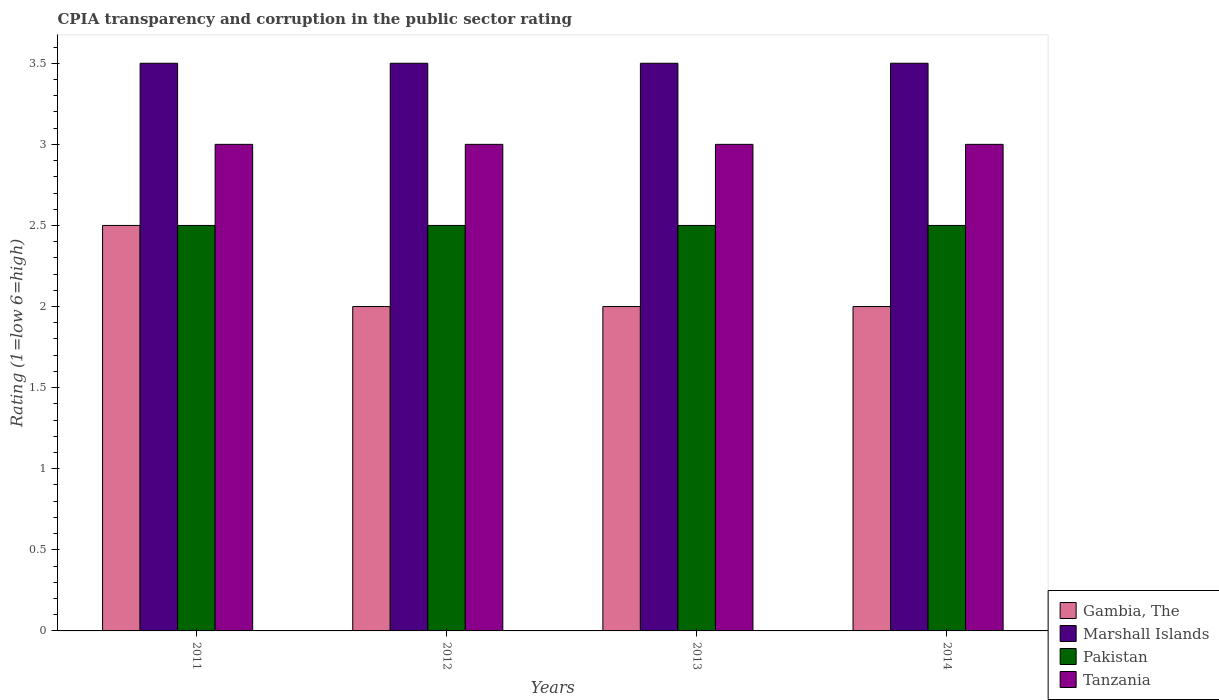Are the number of bars per tick equal to the number of legend labels?
Give a very brief answer. Yes. How many bars are there on the 2nd tick from the left?
Keep it short and to the point. 4. What is the label of the 4th group of bars from the left?
Ensure brevity in your answer.  2014. Across all years, what is the maximum CPIA rating in Pakistan?
Offer a terse response. 2.5. In the year 2014, what is the difference between the CPIA rating in Pakistan and CPIA rating in Gambia, The?
Offer a very short reply. 0.5. What is the ratio of the CPIA rating in Tanzania in 2013 to that in 2014?
Keep it short and to the point. 1. Is the CPIA rating in Marshall Islands in 2011 less than that in 2014?
Offer a terse response. No. What is the difference between the highest and the second highest CPIA rating in Marshall Islands?
Offer a very short reply. 0. In how many years, is the CPIA rating in Marshall Islands greater than the average CPIA rating in Marshall Islands taken over all years?
Keep it short and to the point. 0. Is the sum of the CPIA rating in Tanzania in 2011 and 2014 greater than the maximum CPIA rating in Marshall Islands across all years?
Provide a short and direct response. Yes. What does the 1st bar from the left in 2013 represents?
Ensure brevity in your answer.  Gambia, The. What does the 3rd bar from the right in 2013 represents?
Offer a terse response. Marshall Islands. Is it the case that in every year, the sum of the CPIA rating in Tanzania and CPIA rating in Gambia, The is greater than the CPIA rating in Marshall Islands?
Offer a very short reply. Yes. Are all the bars in the graph horizontal?
Offer a very short reply. No. What is the difference between two consecutive major ticks on the Y-axis?
Ensure brevity in your answer.  0.5. What is the title of the graph?
Give a very brief answer. CPIA transparency and corruption in the public sector rating. What is the label or title of the Y-axis?
Offer a terse response. Rating (1=low 6=high). What is the Rating (1=low 6=high) in Marshall Islands in 2011?
Offer a terse response. 3.5. What is the Rating (1=low 6=high) in Tanzania in 2012?
Ensure brevity in your answer.  3. What is the Rating (1=low 6=high) in Tanzania in 2013?
Provide a short and direct response. 3. What is the Rating (1=low 6=high) in Marshall Islands in 2014?
Offer a very short reply. 3.5. What is the Rating (1=low 6=high) in Tanzania in 2014?
Provide a short and direct response. 3. Across all years, what is the maximum Rating (1=low 6=high) in Marshall Islands?
Your answer should be compact. 3.5. Across all years, what is the maximum Rating (1=low 6=high) of Pakistan?
Ensure brevity in your answer.  2.5. Across all years, what is the maximum Rating (1=low 6=high) of Tanzania?
Provide a succinct answer. 3. Across all years, what is the minimum Rating (1=low 6=high) of Gambia, The?
Ensure brevity in your answer.  2. Across all years, what is the minimum Rating (1=low 6=high) of Marshall Islands?
Your response must be concise. 3.5. Across all years, what is the minimum Rating (1=low 6=high) in Pakistan?
Offer a very short reply. 2.5. What is the total Rating (1=low 6=high) of Tanzania in the graph?
Make the answer very short. 12. What is the difference between the Rating (1=low 6=high) of Gambia, The in 2011 and that in 2012?
Your answer should be very brief. 0.5. What is the difference between the Rating (1=low 6=high) in Marshall Islands in 2011 and that in 2012?
Provide a succinct answer. 0. What is the difference between the Rating (1=low 6=high) in Pakistan in 2011 and that in 2012?
Make the answer very short. 0. What is the difference between the Rating (1=low 6=high) in Tanzania in 2011 and that in 2012?
Provide a short and direct response. 0. What is the difference between the Rating (1=low 6=high) in Gambia, The in 2011 and that in 2013?
Keep it short and to the point. 0.5. What is the difference between the Rating (1=low 6=high) in Tanzania in 2011 and that in 2013?
Keep it short and to the point. 0. What is the difference between the Rating (1=low 6=high) of Tanzania in 2011 and that in 2014?
Provide a succinct answer. 0. What is the difference between the Rating (1=low 6=high) of Marshall Islands in 2012 and that in 2013?
Provide a short and direct response. 0. What is the difference between the Rating (1=low 6=high) of Pakistan in 2012 and that in 2013?
Offer a terse response. 0. What is the difference between the Rating (1=low 6=high) of Tanzania in 2012 and that in 2013?
Your answer should be compact. 0. What is the difference between the Rating (1=low 6=high) in Marshall Islands in 2012 and that in 2014?
Your answer should be very brief. 0. What is the difference between the Rating (1=low 6=high) of Marshall Islands in 2013 and that in 2014?
Your answer should be very brief. 0. What is the difference between the Rating (1=low 6=high) in Gambia, The in 2011 and the Rating (1=low 6=high) in Marshall Islands in 2012?
Provide a succinct answer. -1. What is the difference between the Rating (1=low 6=high) in Gambia, The in 2011 and the Rating (1=low 6=high) in Pakistan in 2012?
Ensure brevity in your answer.  0. What is the difference between the Rating (1=low 6=high) of Marshall Islands in 2011 and the Rating (1=low 6=high) of Pakistan in 2012?
Give a very brief answer. 1. What is the difference between the Rating (1=low 6=high) of Gambia, The in 2011 and the Rating (1=low 6=high) of Marshall Islands in 2013?
Offer a terse response. -1. What is the difference between the Rating (1=low 6=high) of Gambia, The in 2011 and the Rating (1=low 6=high) of Pakistan in 2013?
Your response must be concise. 0. What is the difference between the Rating (1=low 6=high) of Gambia, The in 2011 and the Rating (1=low 6=high) of Marshall Islands in 2014?
Provide a short and direct response. -1. What is the difference between the Rating (1=low 6=high) in Marshall Islands in 2011 and the Rating (1=low 6=high) in Pakistan in 2014?
Your answer should be very brief. 1. What is the difference between the Rating (1=low 6=high) of Pakistan in 2011 and the Rating (1=low 6=high) of Tanzania in 2014?
Provide a short and direct response. -0.5. What is the difference between the Rating (1=low 6=high) of Gambia, The in 2012 and the Rating (1=low 6=high) of Marshall Islands in 2013?
Give a very brief answer. -1.5. What is the difference between the Rating (1=low 6=high) in Marshall Islands in 2012 and the Rating (1=low 6=high) in Tanzania in 2013?
Offer a terse response. 0.5. What is the difference between the Rating (1=low 6=high) of Pakistan in 2012 and the Rating (1=low 6=high) of Tanzania in 2013?
Offer a terse response. -0.5. What is the difference between the Rating (1=low 6=high) in Pakistan in 2012 and the Rating (1=low 6=high) in Tanzania in 2014?
Your response must be concise. -0.5. What is the difference between the Rating (1=low 6=high) of Gambia, The in 2013 and the Rating (1=low 6=high) of Pakistan in 2014?
Ensure brevity in your answer.  -0.5. What is the difference between the Rating (1=low 6=high) of Gambia, The in 2013 and the Rating (1=low 6=high) of Tanzania in 2014?
Your answer should be very brief. -1. What is the difference between the Rating (1=low 6=high) of Marshall Islands in 2013 and the Rating (1=low 6=high) of Pakistan in 2014?
Make the answer very short. 1. What is the average Rating (1=low 6=high) in Gambia, The per year?
Provide a short and direct response. 2.12. What is the average Rating (1=low 6=high) in Marshall Islands per year?
Offer a very short reply. 3.5. What is the average Rating (1=low 6=high) in Pakistan per year?
Give a very brief answer. 2.5. In the year 2011, what is the difference between the Rating (1=low 6=high) of Gambia, The and Rating (1=low 6=high) of Tanzania?
Provide a short and direct response. -0.5. In the year 2011, what is the difference between the Rating (1=low 6=high) in Marshall Islands and Rating (1=low 6=high) in Tanzania?
Offer a very short reply. 0.5. In the year 2011, what is the difference between the Rating (1=low 6=high) of Pakistan and Rating (1=low 6=high) of Tanzania?
Ensure brevity in your answer.  -0.5. In the year 2012, what is the difference between the Rating (1=low 6=high) in Gambia, The and Rating (1=low 6=high) in Tanzania?
Give a very brief answer. -1. In the year 2013, what is the difference between the Rating (1=low 6=high) of Gambia, The and Rating (1=low 6=high) of Marshall Islands?
Offer a terse response. -1.5. In the year 2013, what is the difference between the Rating (1=low 6=high) in Gambia, The and Rating (1=low 6=high) in Tanzania?
Ensure brevity in your answer.  -1. In the year 2013, what is the difference between the Rating (1=low 6=high) of Marshall Islands and Rating (1=low 6=high) of Pakistan?
Offer a very short reply. 1. In the year 2013, what is the difference between the Rating (1=low 6=high) in Pakistan and Rating (1=low 6=high) in Tanzania?
Offer a very short reply. -0.5. In the year 2014, what is the difference between the Rating (1=low 6=high) of Gambia, The and Rating (1=low 6=high) of Marshall Islands?
Provide a short and direct response. -1.5. In the year 2014, what is the difference between the Rating (1=low 6=high) of Gambia, The and Rating (1=low 6=high) of Pakistan?
Give a very brief answer. -0.5. In the year 2014, what is the difference between the Rating (1=low 6=high) in Gambia, The and Rating (1=low 6=high) in Tanzania?
Offer a terse response. -1. In the year 2014, what is the difference between the Rating (1=low 6=high) of Marshall Islands and Rating (1=low 6=high) of Pakistan?
Give a very brief answer. 1. What is the ratio of the Rating (1=low 6=high) of Marshall Islands in 2011 to that in 2012?
Your response must be concise. 1. What is the ratio of the Rating (1=low 6=high) of Tanzania in 2011 to that in 2012?
Give a very brief answer. 1. What is the ratio of the Rating (1=low 6=high) in Tanzania in 2011 to that in 2013?
Ensure brevity in your answer.  1. What is the ratio of the Rating (1=low 6=high) in Pakistan in 2011 to that in 2014?
Your response must be concise. 1. What is the ratio of the Rating (1=low 6=high) of Tanzania in 2011 to that in 2014?
Give a very brief answer. 1. What is the ratio of the Rating (1=low 6=high) of Gambia, The in 2012 to that in 2013?
Offer a very short reply. 1. What is the ratio of the Rating (1=low 6=high) of Marshall Islands in 2012 to that in 2013?
Your answer should be very brief. 1. What is the ratio of the Rating (1=low 6=high) of Tanzania in 2012 to that in 2013?
Your answer should be compact. 1. What is the ratio of the Rating (1=low 6=high) in Tanzania in 2012 to that in 2014?
Provide a succinct answer. 1. What is the ratio of the Rating (1=low 6=high) in Pakistan in 2013 to that in 2014?
Your answer should be very brief. 1. What is the ratio of the Rating (1=low 6=high) of Tanzania in 2013 to that in 2014?
Provide a short and direct response. 1. What is the difference between the highest and the second highest Rating (1=low 6=high) of Gambia, The?
Make the answer very short. 0.5. What is the difference between the highest and the second highest Rating (1=low 6=high) of Marshall Islands?
Your answer should be compact. 0. What is the difference between the highest and the second highest Rating (1=low 6=high) in Tanzania?
Give a very brief answer. 0. What is the difference between the highest and the lowest Rating (1=low 6=high) of Marshall Islands?
Offer a very short reply. 0. 